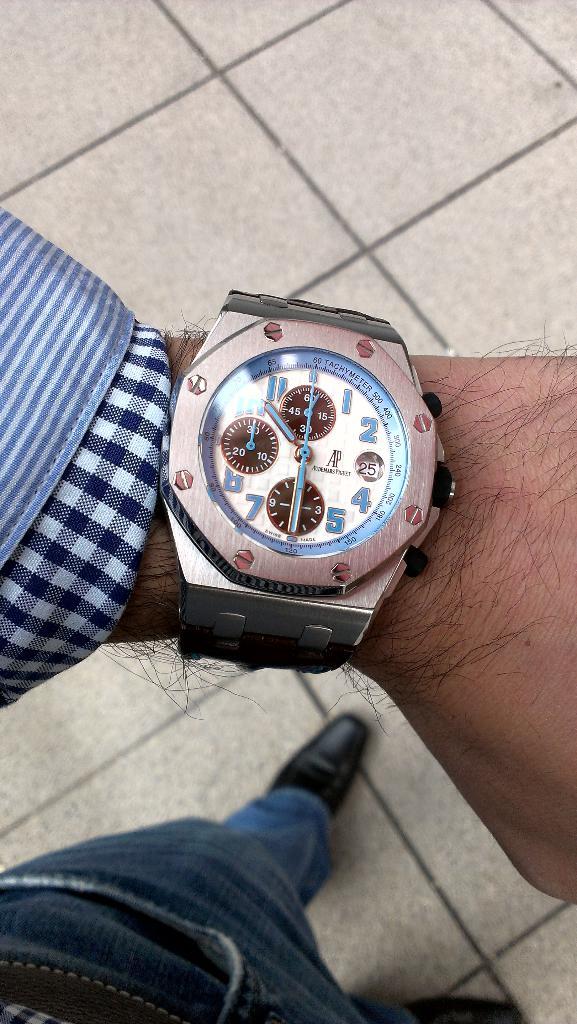What is the day of the month, according to the watch?
Give a very brief answer. 25. 